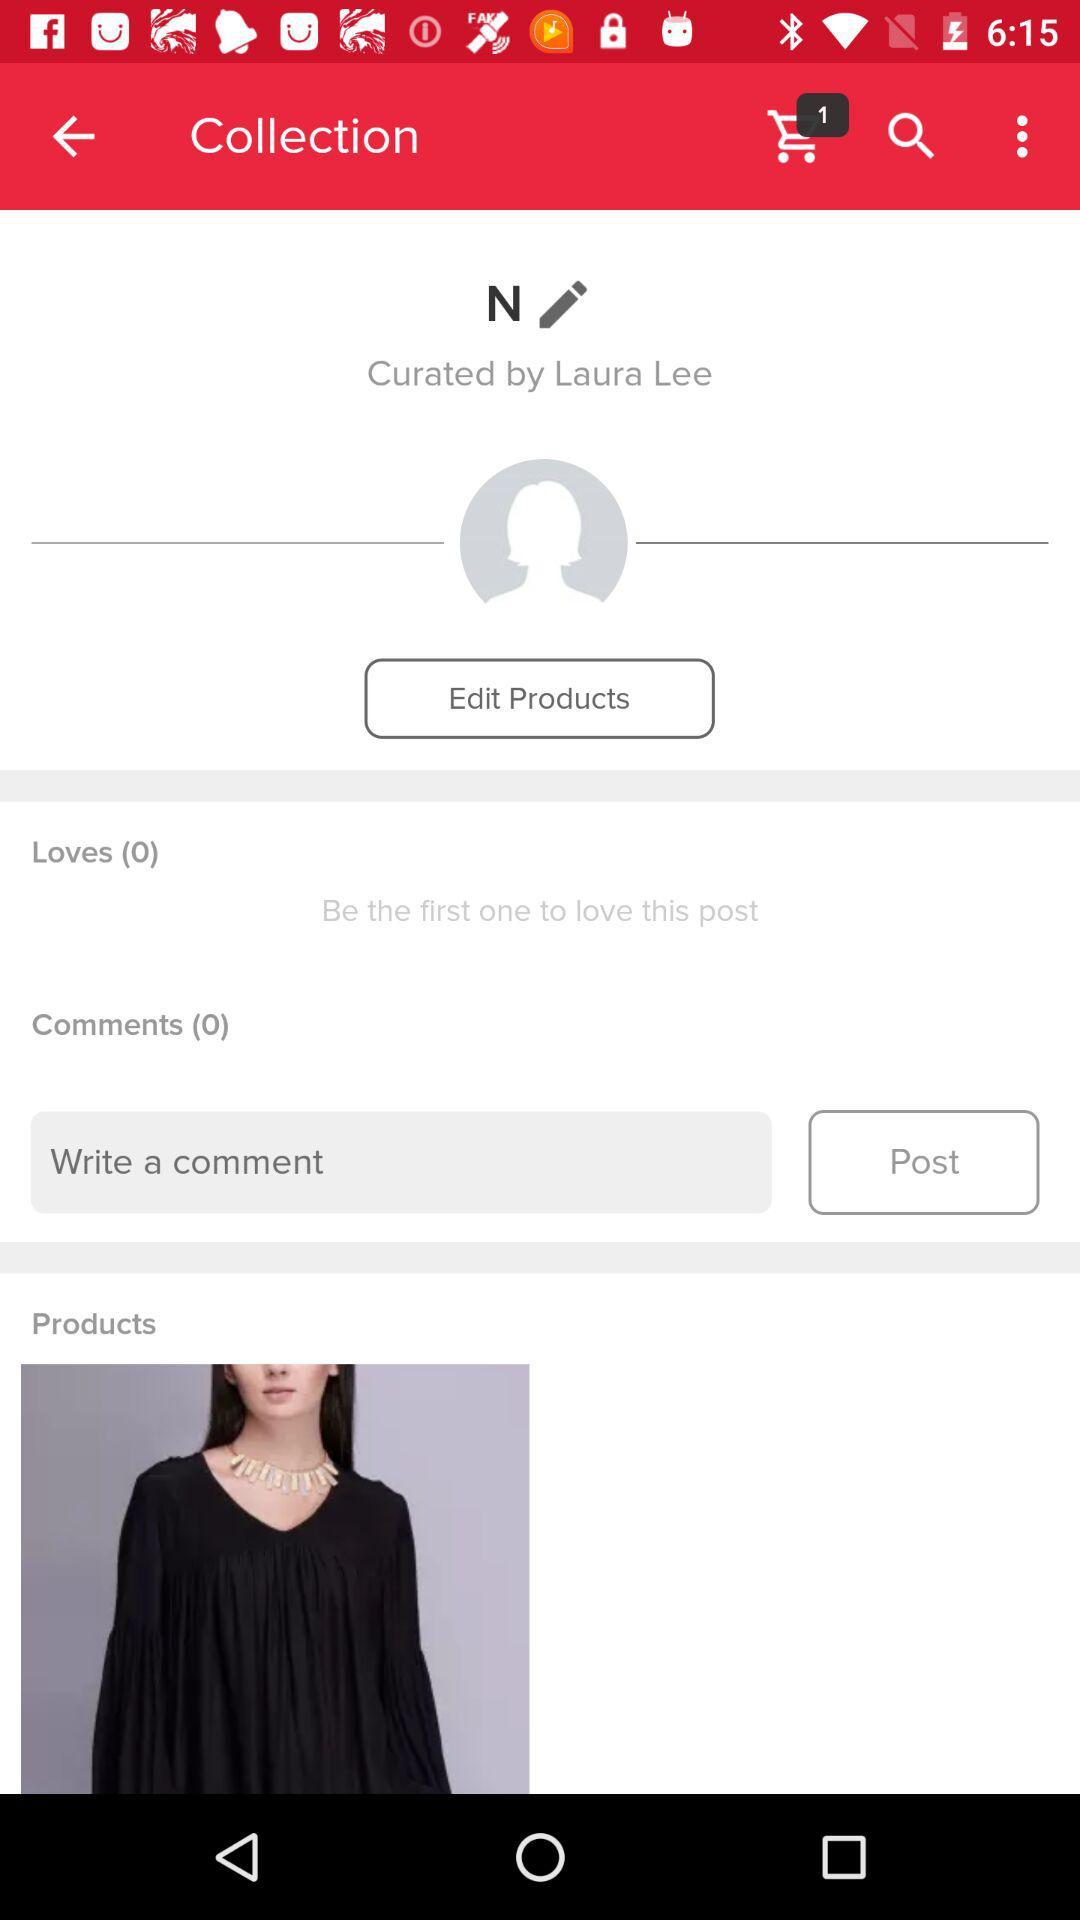How many more loves than comments are there?
Answer the question using a single word or phrase. 0 